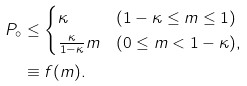<formula> <loc_0><loc_0><loc_500><loc_500>P _ { \circ } & \leq \begin{cases} \kappa & ( 1 - \kappa \leq m \leq 1 ) \\ \frac { \kappa } { 1 - \kappa } m & ( 0 \leq m < 1 - \kappa ) , \end{cases} \\ & \equiv f ( m ) .</formula> 